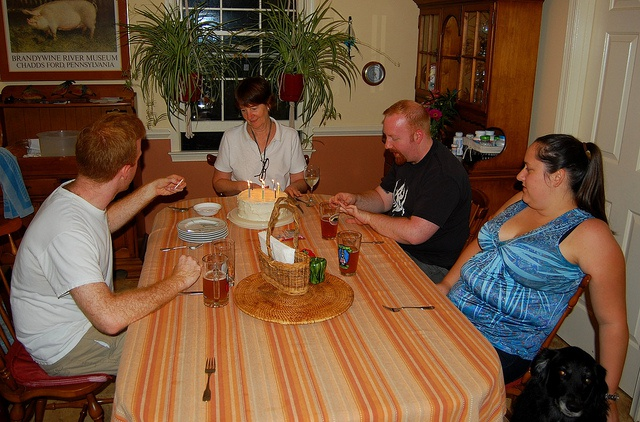Describe the objects in this image and their specific colors. I can see dining table in maroon, brown, and tan tones, people in maroon, black, brown, salmon, and blue tones, people in maroon, darkgray, and gray tones, people in maroon, black, and brown tones, and potted plant in maroon, black, darkgreen, and gray tones in this image. 